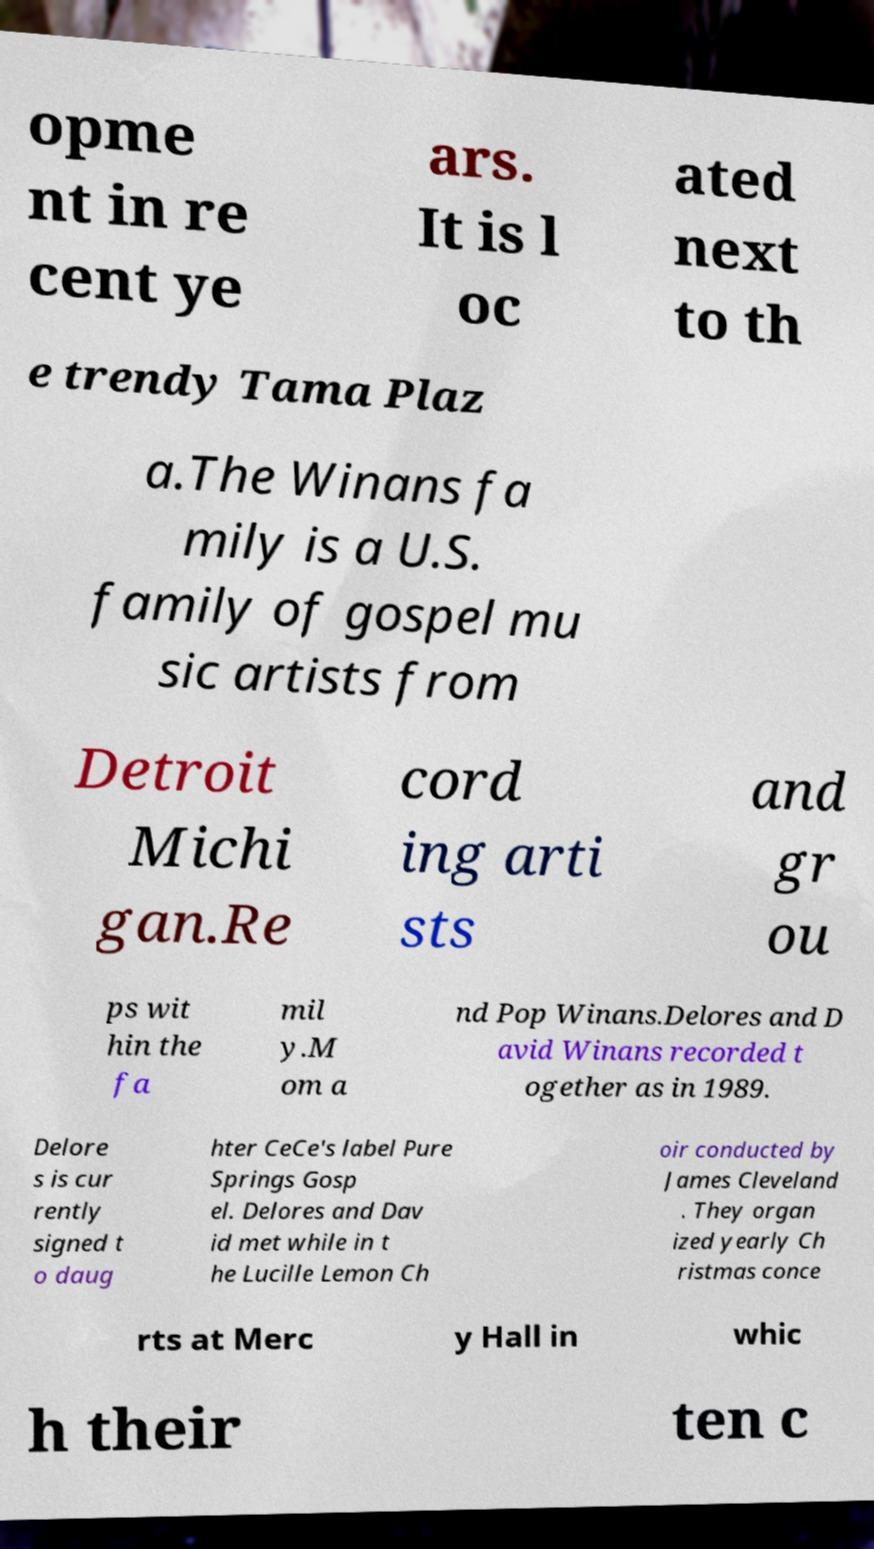Can you read and provide the text displayed in the image?This photo seems to have some interesting text. Can you extract and type it out for me? opme nt in re cent ye ars. It is l oc ated next to th e trendy Tama Plaz a.The Winans fa mily is a U.S. family of gospel mu sic artists from Detroit Michi gan.Re cord ing arti sts and gr ou ps wit hin the fa mil y.M om a nd Pop Winans.Delores and D avid Winans recorded t ogether as in 1989. Delore s is cur rently signed t o daug hter CeCe's label Pure Springs Gosp el. Delores and Dav id met while in t he Lucille Lemon Ch oir conducted by James Cleveland . They organ ized yearly Ch ristmas conce rts at Merc y Hall in whic h their ten c 